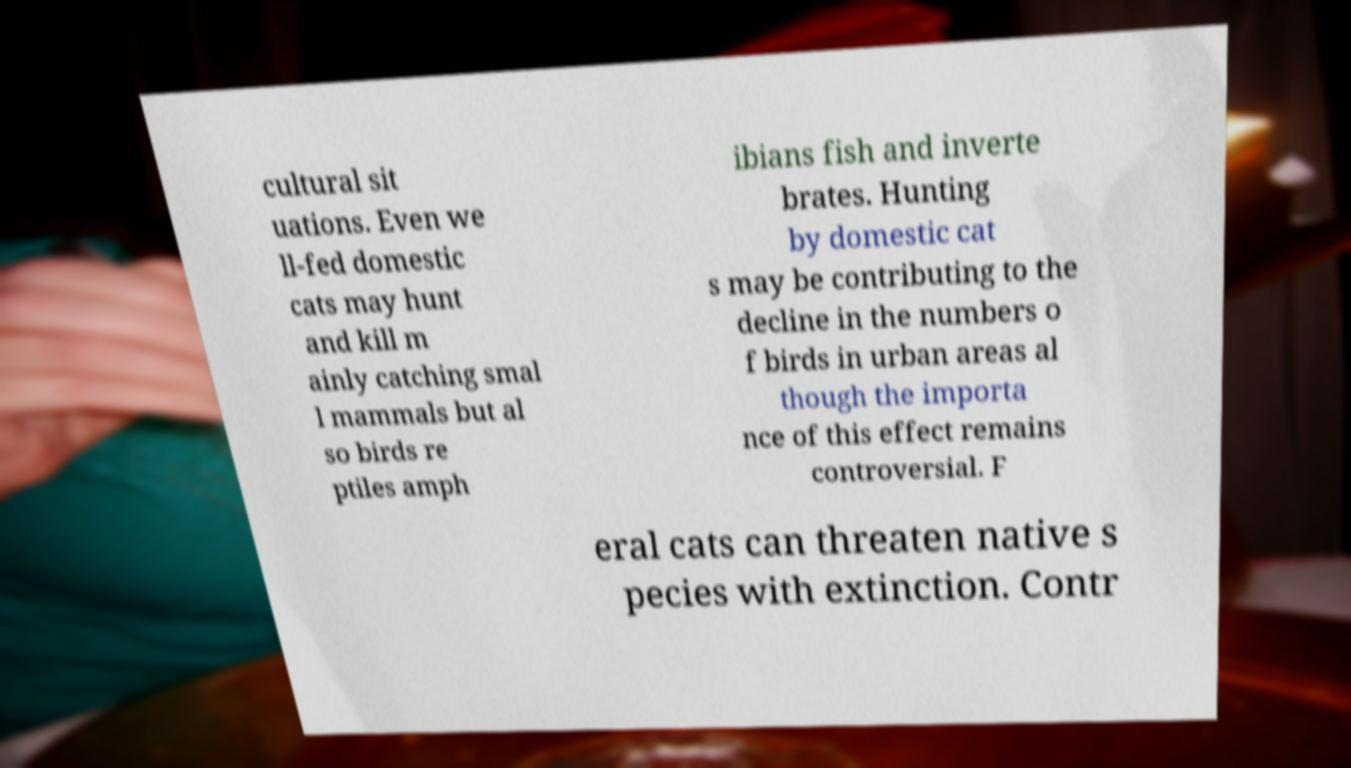Please read and relay the text visible in this image. What does it say? cultural sit uations. Even we ll-fed domestic cats may hunt and kill m ainly catching smal l mammals but al so birds re ptiles amph ibians fish and inverte brates. Hunting by domestic cat s may be contributing to the decline in the numbers o f birds in urban areas al though the importa nce of this effect remains controversial. F eral cats can threaten native s pecies with extinction. Contr 